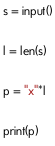Convert code to text. <code><loc_0><loc_0><loc_500><loc_500><_Python_>s = input()

l = len(s)

p = "x"*l

print(p)</code> 